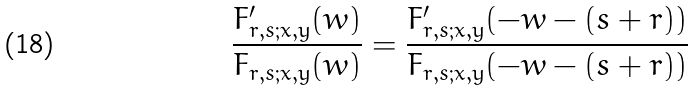Convert formula to latex. <formula><loc_0><loc_0><loc_500><loc_500>\frac { F _ { r , s ; x , y } ^ { \prime } ( w ) } { F _ { r , s ; x , y } ( w ) } = \frac { F _ { r , s ; x , y } ^ { \prime } ( - w - ( s + r ) ) } { F _ { r , s ; x , y } ( - w - ( s + r ) ) }</formula> 